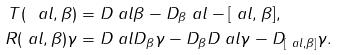Convert formula to latex. <formula><loc_0><loc_0><loc_500><loc_500>T ( \ a l , \beta ) & = D _ { \ } a l \beta - D _ { \beta } \ a l - [ \ a l , \beta ] , \\ R ( \ a l , \beta ) \gamma & = D _ { \ } a l D _ { \beta } \gamma - D _ { \beta } D _ { \ } a l \gamma - D _ { [ \ a l , \beta ] } \gamma .</formula> 